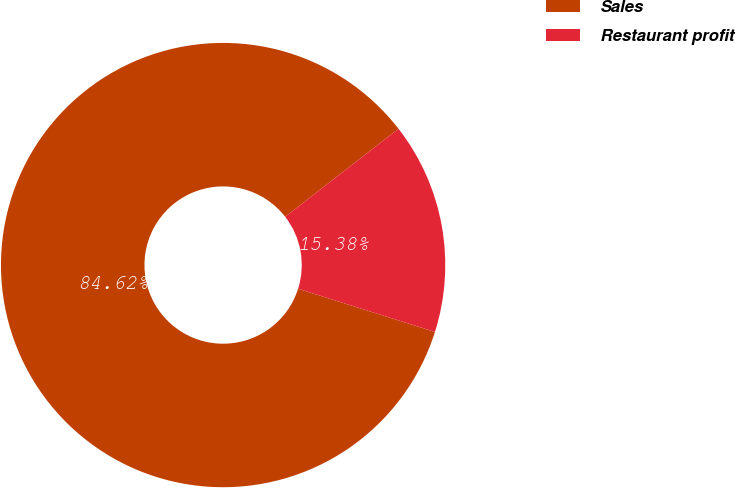Convert chart to OTSL. <chart><loc_0><loc_0><loc_500><loc_500><pie_chart><fcel>Sales<fcel>Restaurant profit<nl><fcel>84.62%<fcel>15.38%<nl></chart> 